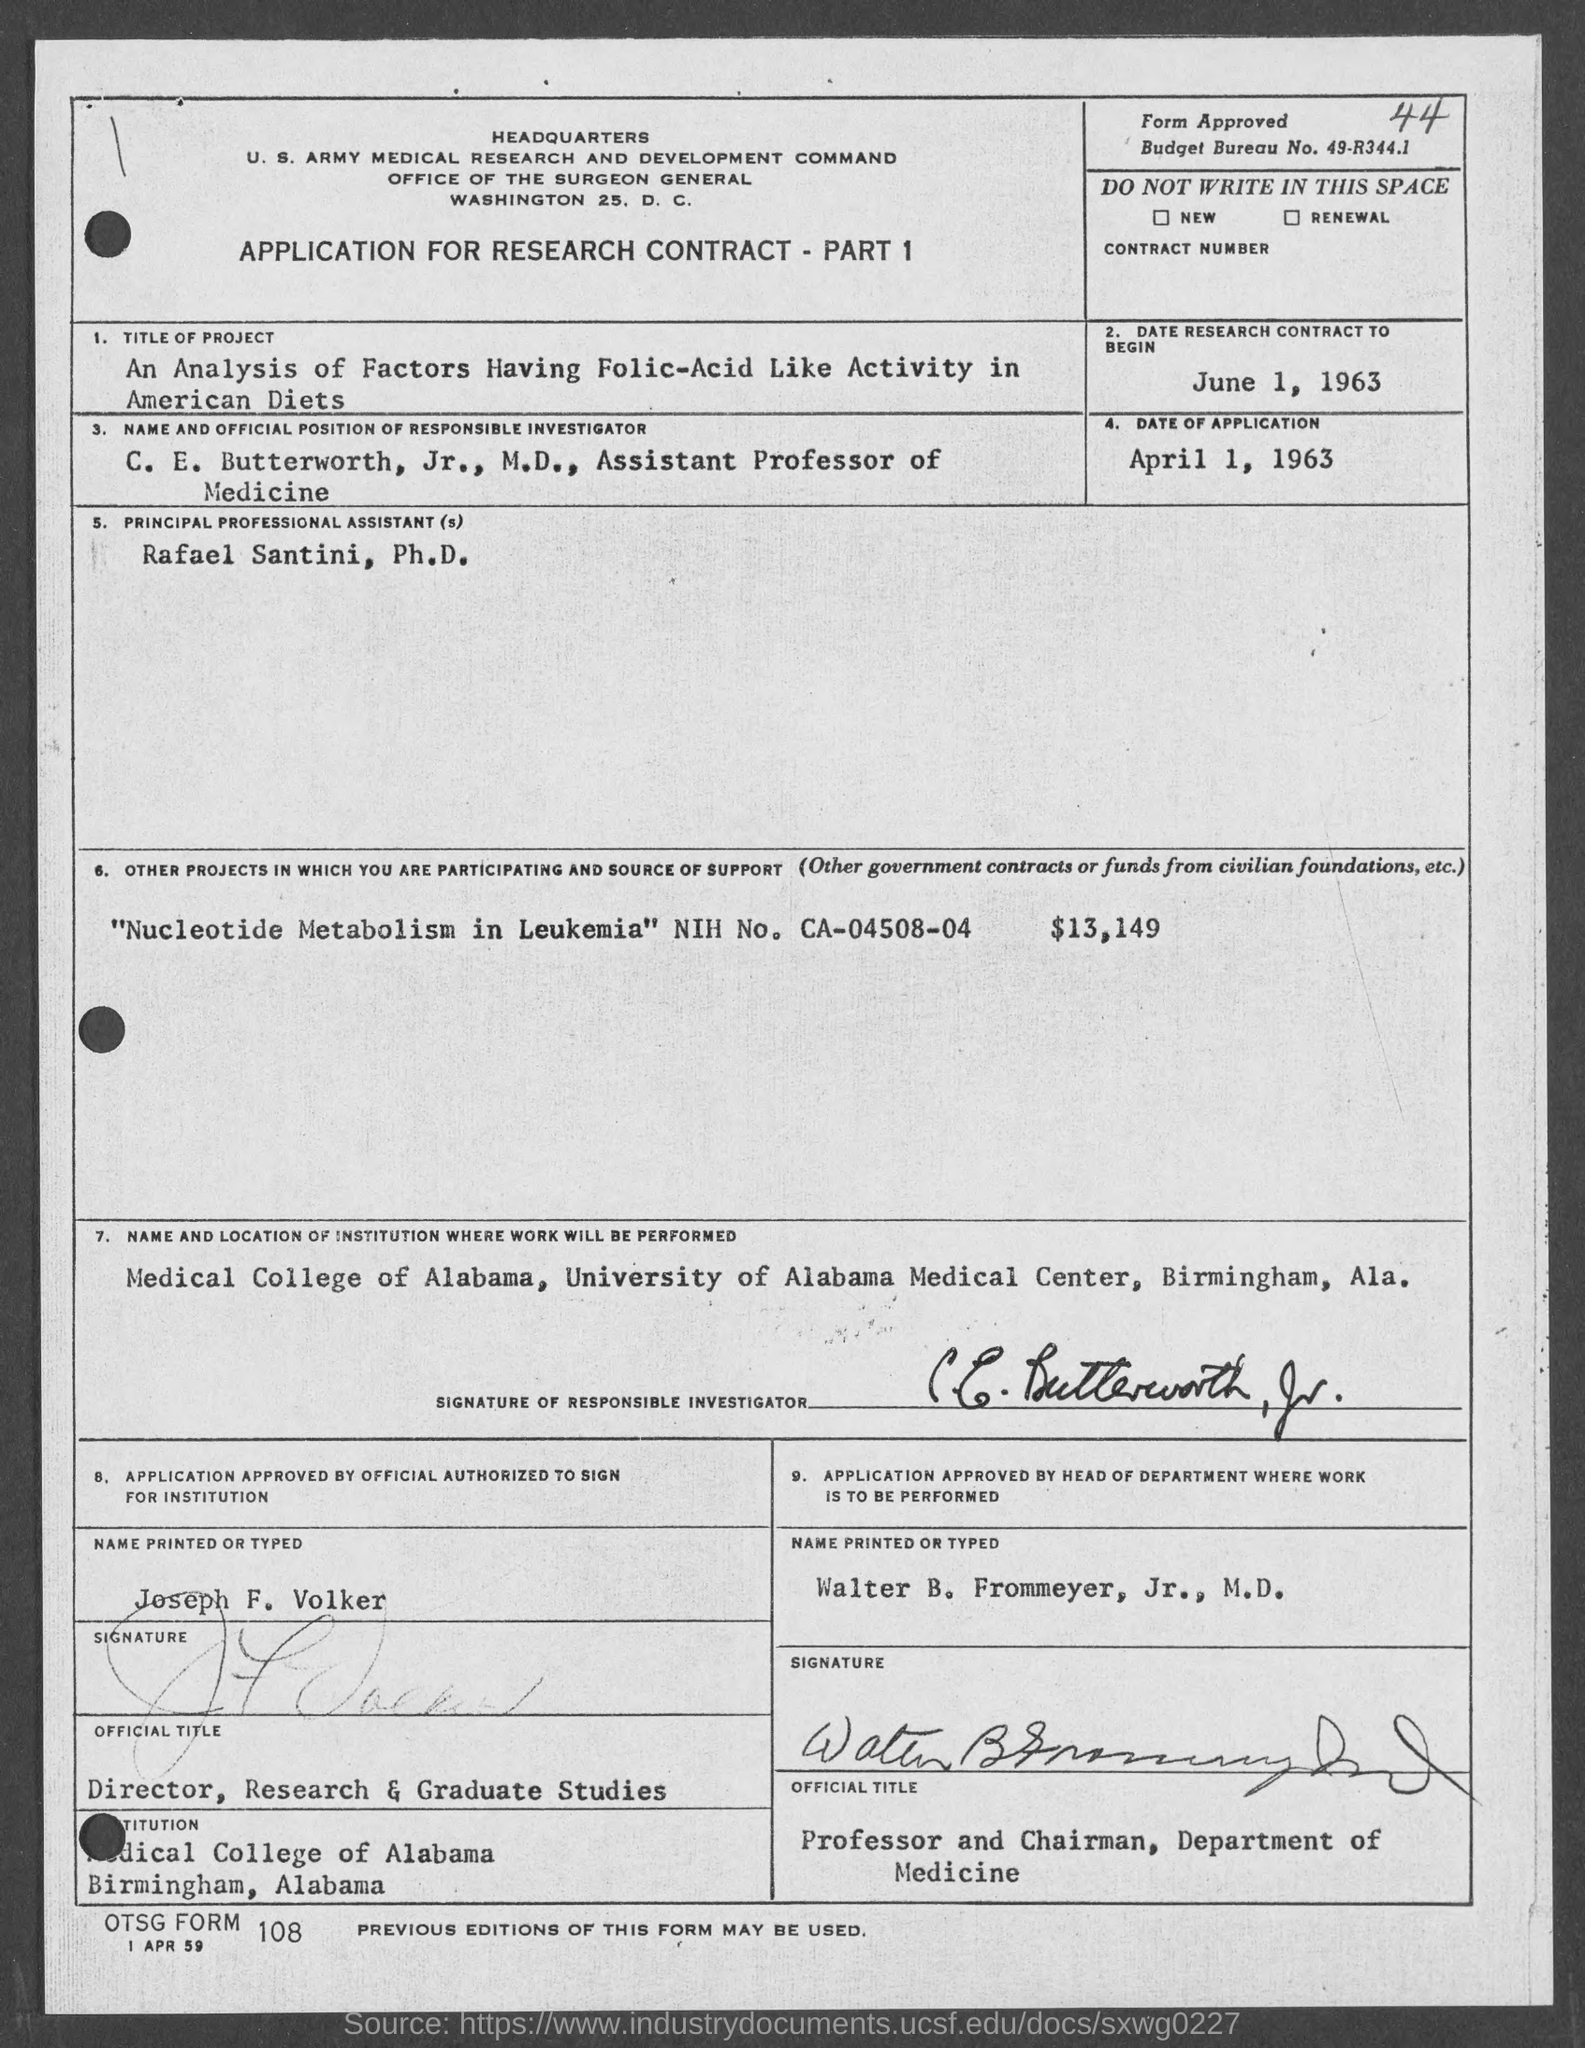What is the Budget Bureau No.?
Offer a terse response. 49-R344.1. When will the research contract begin?
Give a very brief answer. June 1, 1963. What is the Date of Application?
Keep it short and to the point. April 1, 1963. Who is the Principal Professional Assistant?
Make the answer very short. Rafael Santini. 